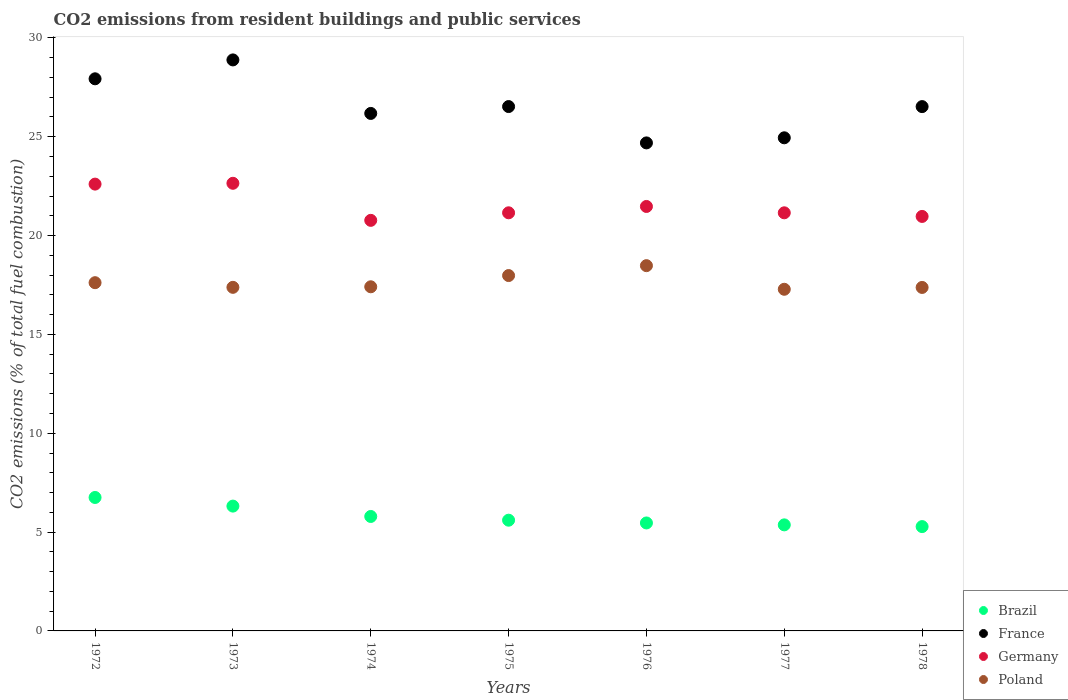Is the number of dotlines equal to the number of legend labels?
Ensure brevity in your answer.  Yes. What is the total CO2 emitted in Poland in 1975?
Offer a terse response. 17.98. Across all years, what is the maximum total CO2 emitted in Poland?
Your response must be concise. 18.48. Across all years, what is the minimum total CO2 emitted in France?
Your answer should be very brief. 24.69. In which year was the total CO2 emitted in Germany maximum?
Keep it short and to the point. 1973. In which year was the total CO2 emitted in France minimum?
Offer a very short reply. 1976. What is the total total CO2 emitted in France in the graph?
Your response must be concise. 185.68. What is the difference between the total CO2 emitted in Germany in 1977 and that in 1978?
Provide a short and direct response. 0.18. What is the difference between the total CO2 emitted in Germany in 1973 and the total CO2 emitted in Brazil in 1972?
Offer a very short reply. 15.89. What is the average total CO2 emitted in Poland per year?
Give a very brief answer. 17.65. In the year 1972, what is the difference between the total CO2 emitted in Germany and total CO2 emitted in Poland?
Provide a short and direct response. 4.99. What is the ratio of the total CO2 emitted in Poland in 1973 to that in 1976?
Ensure brevity in your answer.  0.94. What is the difference between the highest and the second highest total CO2 emitted in Poland?
Offer a terse response. 0.5. What is the difference between the highest and the lowest total CO2 emitted in France?
Your answer should be compact. 4.2. Is the sum of the total CO2 emitted in Germany in 1972 and 1976 greater than the maximum total CO2 emitted in Brazil across all years?
Offer a terse response. Yes. Does the total CO2 emitted in Poland monotonically increase over the years?
Keep it short and to the point. No. Is the total CO2 emitted in Brazil strictly greater than the total CO2 emitted in France over the years?
Your answer should be very brief. No. How many years are there in the graph?
Your answer should be very brief. 7. Are the values on the major ticks of Y-axis written in scientific E-notation?
Give a very brief answer. No. Does the graph contain any zero values?
Make the answer very short. No. Where does the legend appear in the graph?
Ensure brevity in your answer.  Bottom right. What is the title of the graph?
Your answer should be compact. CO2 emissions from resident buildings and public services. What is the label or title of the X-axis?
Your answer should be very brief. Years. What is the label or title of the Y-axis?
Offer a very short reply. CO2 emissions (% of total fuel combustion). What is the CO2 emissions (% of total fuel combustion) in Brazil in 1972?
Your answer should be very brief. 6.75. What is the CO2 emissions (% of total fuel combustion) of France in 1972?
Ensure brevity in your answer.  27.93. What is the CO2 emissions (% of total fuel combustion) of Germany in 1972?
Offer a terse response. 22.6. What is the CO2 emissions (% of total fuel combustion) of Poland in 1972?
Ensure brevity in your answer.  17.62. What is the CO2 emissions (% of total fuel combustion) in Brazil in 1973?
Provide a short and direct response. 6.31. What is the CO2 emissions (% of total fuel combustion) of France in 1973?
Make the answer very short. 28.89. What is the CO2 emissions (% of total fuel combustion) of Germany in 1973?
Your answer should be compact. 22.65. What is the CO2 emissions (% of total fuel combustion) in Poland in 1973?
Offer a terse response. 17.38. What is the CO2 emissions (% of total fuel combustion) of Brazil in 1974?
Your response must be concise. 5.79. What is the CO2 emissions (% of total fuel combustion) of France in 1974?
Keep it short and to the point. 26.18. What is the CO2 emissions (% of total fuel combustion) of Germany in 1974?
Your answer should be very brief. 20.77. What is the CO2 emissions (% of total fuel combustion) of Poland in 1974?
Your answer should be very brief. 17.41. What is the CO2 emissions (% of total fuel combustion) of Brazil in 1975?
Your response must be concise. 5.6. What is the CO2 emissions (% of total fuel combustion) in France in 1975?
Ensure brevity in your answer.  26.53. What is the CO2 emissions (% of total fuel combustion) in Germany in 1975?
Offer a terse response. 21.15. What is the CO2 emissions (% of total fuel combustion) of Poland in 1975?
Give a very brief answer. 17.98. What is the CO2 emissions (% of total fuel combustion) in Brazil in 1976?
Make the answer very short. 5.46. What is the CO2 emissions (% of total fuel combustion) of France in 1976?
Ensure brevity in your answer.  24.69. What is the CO2 emissions (% of total fuel combustion) in Germany in 1976?
Your response must be concise. 21.47. What is the CO2 emissions (% of total fuel combustion) in Poland in 1976?
Provide a succinct answer. 18.48. What is the CO2 emissions (% of total fuel combustion) of Brazil in 1977?
Give a very brief answer. 5.37. What is the CO2 emissions (% of total fuel combustion) of France in 1977?
Offer a very short reply. 24.95. What is the CO2 emissions (% of total fuel combustion) in Germany in 1977?
Ensure brevity in your answer.  21.15. What is the CO2 emissions (% of total fuel combustion) in Poland in 1977?
Give a very brief answer. 17.28. What is the CO2 emissions (% of total fuel combustion) of Brazil in 1978?
Your answer should be compact. 5.28. What is the CO2 emissions (% of total fuel combustion) in France in 1978?
Give a very brief answer. 26.52. What is the CO2 emissions (% of total fuel combustion) in Germany in 1978?
Make the answer very short. 20.97. What is the CO2 emissions (% of total fuel combustion) in Poland in 1978?
Keep it short and to the point. 17.38. Across all years, what is the maximum CO2 emissions (% of total fuel combustion) in Brazil?
Keep it short and to the point. 6.75. Across all years, what is the maximum CO2 emissions (% of total fuel combustion) of France?
Offer a terse response. 28.89. Across all years, what is the maximum CO2 emissions (% of total fuel combustion) in Germany?
Your answer should be compact. 22.65. Across all years, what is the maximum CO2 emissions (% of total fuel combustion) in Poland?
Offer a very short reply. 18.48. Across all years, what is the minimum CO2 emissions (% of total fuel combustion) in Brazil?
Ensure brevity in your answer.  5.28. Across all years, what is the minimum CO2 emissions (% of total fuel combustion) in France?
Provide a succinct answer. 24.69. Across all years, what is the minimum CO2 emissions (% of total fuel combustion) in Germany?
Offer a terse response. 20.77. Across all years, what is the minimum CO2 emissions (% of total fuel combustion) in Poland?
Ensure brevity in your answer.  17.28. What is the total CO2 emissions (% of total fuel combustion) in Brazil in the graph?
Provide a succinct answer. 40.56. What is the total CO2 emissions (% of total fuel combustion) in France in the graph?
Provide a succinct answer. 185.68. What is the total CO2 emissions (% of total fuel combustion) in Germany in the graph?
Provide a short and direct response. 150.76. What is the total CO2 emissions (% of total fuel combustion) in Poland in the graph?
Your answer should be compact. 123.52. What is the difference between the CO2 emissions (% of total fuel combustion) of Brazil in 1972 and that in 1973?
Offer a very short reply. 0.44. What is the difference between the CO2 emissions (% of total fuel combustion) of France in 1972 and that in 1973?
Offer a very short reply. -0.96. What is the difference between the CO2 emissions (% of total fuel combustion) in Germany in 1972 and that in 1973?
Ensure brevity in your answer.  -0.04. What is the difference between the CO2 emissions (% of total fuel combustion) of Poland in 1972 and that in 1973?
Make the answer very short. 0.24. What is the difference between the CO2 emissions (% of total fuel combustion) in Brazil in 1972 and that in 1974?
Offer a terse response. 0.96. What is the difference between the CO2 emissions (% of total fuel combustion) in France in 1972 and that in 1974?
Offer a very short reply. 1.75. What is the difference between the CO2 emissions (% of total fuel combustion) of Germany in 1972 and that in 1974?
Your response must be concise. 1.83. What is the difference between the CO2 emissions (% of total fuel combustion) of Poland in 1972 and that in 1974?
Your response must be concise. 0.21. What is the difference between the CO2 emissions (% of total fuel combustion) in Brazil in 1972 and that in 1975?
Offer a very short reply. 1.15. What is the difference between the CO2 emissions (% of total fuel combustion) of France in 1972 and that in 1975?
Offer a terse response. 1.4. What is the difference between the CO2 emissions (% of total fuel combustion) in Germany in 1972 and that in 1975?
Provide a succinct answer. 1.45. What is the difference between the CO2 emissions (% of total fuel combustion) in Poland in 1972 and that in 1975?
Provide a short and direct response. -0.36. What is the difference between the CO2 emissions (% of total fuel combustion) of Brazil in 1972 and that in 1976?
Your answer should be compact. 1.29. What is the difference between the CO2 emissions (% of total fuel combustion) of France in 1972 and that in 1976?
Your answer should be very brief. 3.24. What is the difference between the CO2 emissions (% of total fuel combustion) of Germany in 1972 and that in 1976?
Your answer should be compact. 1.13. What is the difference between the CO2 emissions (% of total fuel combustion) of Poland in 1972 and that in 1976?
Keep it short and to the point. -0.86. What is the difference between the CO2 emissions (% of total fuel combustion) of Brazil in 1972 and that in 1977?
Offer a terse response. 1.39. What is the difference between the CO2 emissions (% of total fuel combustion) of France in 1972 and that in 1977?
Keep it short and to the point. 2.98. What is the difference between the CO2 emissions (% of total fuel combustion) of Germany in 1972 and that in 1977?
Your response must be concise. 1.45. What is the difference between the CO2 emissions (% of total fuel combustion) in Poland in 1972 and that in 1977?
Make the answer very short. 0.33. What is the difference between the CO2 emissions (% of total fuel combustion) in Brazil in 1972 and that in 1978?
Make the answer very short. 1.47. What is the difference between the CO2 emissions (% of total fuel combustion) of France in 1972 and that in 1978?
Offer a very short reply. 1.41. What is the difference between the CO2 emissions (% of total fuel combustion) of Germany in 1972 and that in 1978?
Ensure brevity in your answer.  1.63. What is the difference between the CO2 emissions (% of total fuel combustion) in Poland in 1972 and that in 1978?
Your answer should be compact. 0.24. What is the difference between the CO2 emissions (% of total fuel combustion) of Brazil in 1973 and that in 1974?
Keep it short and to the point. 0.52. What is the difference between the CO2 emissions (% of total fuel combustion) in France in 1973 and that in 1974?
Make the answer very short. 2.71. What is the difference between the CO2 emissions (% of total fuel combustion) in Germany in 1973 and that in 1974?
Provide a succinct answer. 1.87. What is the difference between the CO2 emissions (% of total fuel combustion) of Poland in 1973 and that in 1974?
Your answer should be compact. -0.03. What is the difference between the CO2 emissions (% of total fuel combustion) of Brazil in 1973 and that in 1975?
Provide a short and direct response. 0.71. What is the difference between the CO2 emissions (% of total fuel combustion) of France in 1973 and that in 1975?
Provide a short and direct response. 2.36. What is the difference between the CO2 emissions (% of total fuel combustion) of Germany in 1973 and that in 1975?
Make the answer very short. 1.49. What is the difference between the CO2 emissions (% of total fuel combustion) in Poland in 1973 and that in 1975?
Your response must be concise. -0.6. What is the difference between the CO2 emissions (% of total fuel combustion) in Brazil in 1973 and that in 1976?
Your response must be concise. 0.85. What is the difference between the CO2 emissions (% of total fuel combustion) of France in 1973 and that in 1976?
Keep it short and to the point. 4.2. What is the difference between the CO2 emissions (% of total fuel combustion) in Germany in 1973 and that in 1976?
Your answer should be compact. 1.17. What is the difference between the CO2 emissions (% of total fuel combustion) of Poland in 1973 and that in 1976?
Offer a terse response. -1.1. What is the difference between the CO2 emissions (% of total fuel combustion) of Brazil in 1973 and that in 1977?
Offer a very short reply. 0.95. What is the difference between the CO2 emissions (% of total fuel combustion) of France in 1973 and that in 1977?
Your answer should be compact. 3.94. What is the difference between the CO2 emissions (% of total fuel combustion) in Germany in 1973 and that in 1977?
Provide a succinct answer. 1.49. What is the difference between the CO2 emissions (% of total fuel combustion) of Poland in 1973 and that in 1977?
Offer a terse response. 0.1. What is the difference between the CO2 emissions (% of total fuel combustion) of Brazil in 1973 and that in 1978?
Your answer should be very brief. 1.04. What is the difference between the CO2 emissions (% of total fuel combustion) of France in 1973 and that in 1978?
Ensure brevity in your answer.  2.36. What is the difference between the CO2 emissions (% of total fuel combustion) of Germany in 1973 and that in 1978?
Give a very brief answer. 1.68. What is the difference between the CO2 emissions (% of total fuel combustion) of Poland in 1973 and that in 1978?
Offer a very short reply. 0.01. What is the difference between the CO2 emissions (% of total fuel combustion) of Brazil in 1974 and that in 1975?
Provide a succinct answer. 0.19. What is the difference between the CO2 emissions (% of total fuel combustion) of France in 1974 and that in 1975?
Give a very brief answer. -0.35. What is the difference between the CO2 emissions (% of total fuel combustion) in Germany in 1974 and that in 1975?
Your response must be concise. -0.38. What is the difference between the CO2 emissions (% of total fuel combustion) in Poland in 1974 and that in 1975?
Your response must be concise. -0.57. What is the difference between the CO2 emissions (% of total fuel combustion) of Brazil in 1974 and that in 1976?
Your answer should be very brief. 0.33. What is the difference between the CO2 emissions (% of total fuel combustion) of France in 1974 and that in 1976?
Ensure brevity in your answer.  1.49. What is the difference between the CO2 emissions (% of total fuel combustion) in Germany in 1974 and that in 1976?
Your answer should be very brief. -0.7. What is the difference between the CO2 emissions (% of total fuel combustion) of Poland in 1974 and that in 1976?
Your answer should be compact. -1.07. What is the difference between the CO2 emissions (% of total fuel combustion) of Brazil in 1974 and that in 1977?
Provide a succinct answer. 0.42. What is the difference between the CO2 emissions (% of total fuel combustion) in France in 1974 and that in 1977?
Offer a terse response. 1.23. What is the difference between the CO2 emissions (% of total fuel combustion) in Germany in 1974 and that in 1977?
Keep it short and to the point. -0.38. What is the difference between the CO2 emissions (% of total fuel combustion) in Poland in 1974 and that in 1977?
Offer a very short reply. 0.13. What is the difference between the CO2 emissions (% of total fuel combustion) in Brazil in 1974 and that in 1978?
Provide a short and direct response. 0.51. What is the difference between the CO2 emissions (% of total fuel combustion) of France in 1974 and that in 1978?
Provide a succinct answer. -0.35. What is the difference between the CO2 emissions (% of total fuel combustion) in Germany in 1974 and that in 1978?
Provide a short and direct response. -0.2. What is the difference between the CO2 emissions (% of total fuel combustion) of Poland in 1974 and that in 1978?
Offer a very short reply. 0.03. What is the difference between the CO2 emissions (% of total fuel combustion) of Brazil in 1975 and that in 1976?
Provide a succinct answer. 0.14. What is the difference between the CO2 emissions (% of total fuel combustion) of France in 1975 and that in 1976?
Keep it short and to the point. 1.84. What is the difference between the CO2 emissions (% of total fuel combustion) of Germany in 1975 and that in 1976?
Keep it short and to the point. -0.32. What is the difference between the CO2 emissions (% of total fuel combustion) of Poland in 1975 and that in 1976?
Your answer should be compact. -0.5. What is the difference between the CO2 emissions (% of total fuel combustion) of Brazil in 1975 and that in 1977?
Offer a terse response. 0.24. What is the difference between the CO2 emissions (% of total fuel combustion) of France in 1975 and that in 1977?
Keep it short and to the point. 1.58. What is the difference between the CO2 emissions (% of total fuel combustion) of Poland in 1975 and that in 1977?
Your answer should be compact. 0.69. What is the difference between the CO2 emissions (% of total fuel combustion) in Brazil in 1975 and that in 1978?
Ensure brevity in your answer.  0.32. What is the difference between the CO2 emissions (% of total fuel combustion) in France in 1975 and that in 1978?
Your response must be concise. 0. What is the difference between the CO2 emissions (% of total fuel combustion) in Germany in 1975 and that in 1978?
Provide a succinct answer. 0.18. What is the difference between the CO2 emissions (% of total fuel combustion) in Poland in 1975 and that in 1978?
Your answer should be compact. 0.6. What is the difference between the CO2 emissions (% of total fuel combustion) of Brazil in 1976 and that in 1977?
Offer a very short reply. 0.1. What is the difference between the CO2 emissions (% of total fuel combustion) in France in 1976 and that in 1977?
Provide a succinct answer. -0.26. What is the difference between the CO2 emissions (% of total fuel combustion) in Germany in 1976 and that in 1977?
Give a very brief answer. 0.32. What is the difference between the CO2 emissions (% of total fuel combustion) in Poland in 1976 and that in 1977?
Give a very brief answer. 1.2. What is the difference between the CO2 emissions (% of total fuel combustion) in Brazil in 1976 and that in 1978?
Provide a short and direct response. 0.18. What is the difference between the CO2 emissions (% of total fuel combustion) of France in 1976 and that in 1978?
Your response must be concise. -1.84. What is the difference between the CO2 emissions (% of total fuel combustion) of Germany in 1976 and that in 1978?
Your answer should be compact. 0.5. What is the difference between the CO2 emissions (% of total fuel combustion) in Poland in 1976 and that in 1978?
Provide a short and direct response. 1.1. What is the difference between the CO2 emissions (% of total fuel combustion) in Brazil in 1977 and that in 1978?
Give a very brief answer. 0.09. What is the difference between the CO2 emissions (% of total fuel combustion) of France in 1977 and that in 1978?
Your answer should be compact. -1.58. What is the difference between the CO2 emissions (% of total fuel combustion) of Germany in 1977 and that in 1978?
Offer a terse response. 0.18. What is the difference between the CO2 emissions (% of total fuel combustion) in Poland in 1977 and that in 1978?
Give a very brief answer. -0.09. What is the difference between the CO2 emissions (% of total fuel combustion) in Brazil in 1972 and the CO2 emissions (% of total fuel combustion) in France in 1973?
Provide a succinct answer. -22.14. What is the difference between the CO2 emissions (% of total fuel combustion) in Brazil in 1972 and the CO2 emissions (% of total fuel combustion) in Germany in 1973?
Provide a short and direct response. -15.89. What is the difference between the CO2 emissions (% of total fuel combustion) in Brazil in 1972 and the CO2 emissions (% of total fuel combustion) in Poland in 1973?
Your response must be concise. -10.63. What is the difference between the CO2 emissions (% of total fuel combustion) of France in 1972 and the CO2 emissions (% of total fuel combustion) of Germany in 1973?
Make the answer very short. 5.29. What is the difference between the CO2 emissions (% of total fuel combustion) of France in 1972 and the CO2 emissions (% of total fuel combustion) of Poland in 1973?
Ensure brevity in your answer.  10.55. What is the difference between the CO2 emissions (% of total fuel combustion) of Germany in 1972 and the CO2 emissions (% of total fuel combustion) of Poland in 1973?
Keep it short and to the point. 5.22. What is the difference between the CO2 emissions (% of total fuel combustion) of Brazil in 1972 and the CO2 emissions (% of total fuel combustion) of France in 1974?
Provide a short and direct response. -19.43. What is the difference between the CO2 emissions (% of total fuel combustion) in Brazil in 1972 and the CO2 emissions (% of total fuel combustion) in Germany in 1974?
Keep it short and to the point. -14.02. What is the difference between the CO2 emissions (% of total fuel combustion) of Brazil in 1972 and the CO2 emissions (% of total fuel combustion) of Poland in 1974?
Your response must be concise. -10.66. What is the difference between the CO2 emissions (% of total fuel combustion) in France in 1972 and the CO2 emissions (% of total fuel combustion) in Germany in 1974?
Ensure brevity in your answer.  7.16. What is the difference between the CO2 emissions (% of total fuel combustion) of France in 1972 and the CO2 emissions (% of total fuel combustion) of Poland in 1974?
Offer a very short reply. 10.52. What is the difference between the CO2 emissions (% of total fuel combustion) of Germany in 1972 and the CO2 emissions (% of total fuel combustion) of Poland in 1974?
Make the answer very short. 5.19. What is the difference between the CO2 emissions (% of total fuel combustion) in Brazil in 1972 and the CO2 emissions (% of total fuel combustion) in France in 1975?
Ensure brevity in your answer.  -19.78. What is the difference between the CO2 emissions (% of total fuel combustion) in Brazil in 1972 and the CO2 emissions (% of total fuel combustion) in Germany in 1975?
Your answer should be very brief. -14.4. What is the difference between the CO2 emissions (% of total fuel combustion) in Brazil in 1972 and the CO2 emissions (% of total fuel combustion) in Poland in 1975?
Your response must be concise. -11.23. What is the difference between the CO2 emissions (% of total fuel combustion) of France in 1972 and the CO2 emissions (% of total fuel combustion) of Germany in 1975?
Provide a succinct answer. 6.78. What is the difference between the CO2 emissions (% of total fuel combustion) of France in 1972 and the CO2 emissions (% of total fuel combustion) of Poland in 1975?
Offer a very short reply. 9.95. What is the difference between the CO2 emissions (% of total fuel combustion) of Germany in 1972 and the CO2 emissions (% of total fuel combustion) of Poland in 1975?
Make the answer very short. 4.63. What is the difference between the CO2 emissions (% of total fuel combustion) in Brazil in 1972 and the CO2 emissions (% of total fuel combustion) in France in 1976?
Your answer should be compact. -17.94. What is the difference between the CO2 emissions (% of total fuel combustion) of Brazil in 1972 and the CO2 emissions (% of total fuel combustion) of Germany in 1976?
Your answer should be compact. -14.72. What is the difference between the CO2 emissions (% of total fuel combustion) of Brazil in 1972 and the CO2 emissions (% of total fuel combustion) of Poland in 1976?
Your answer should be compact. -11.73. What is the difference between the CO2 emissions (% of total fuel combustion) of France in 1972 and the CO2 emissions (% of total fuel combustion) of Germany in 1976?
Make the answer very short. 6.46. What is the difference between the CO2 emissions (% of total fuel combustion) in France in 1972 and the CO2 emissions (% of total fuel combustion) in Poland in 1976?
Your answer should be compact. 9.45. What is the difference between the CO2 emissions (% of total fuel combustion) of Germany in 1972 and the CO2 emissions (% of total fuel combustion) of Poland in 1976?
Your response must be concise. 4.13. What is the difference between the CO2 emissions (% of total fuel combustion) in Brazil in 1972 and the CO2 emissions (% of total fuel combustion) in France in 1977?
Your answer should be very brief. -18.2. What is the difference between the CO2 emissions (% of total fuel combustion) of Brazil in 1972 and the CO2 emissions (% of total fuel combustion) of Germany in 1977?
Your answer should be very brief. -14.4. What is the difference between the CO2 emissions (% of total fuel combustion) of Brazil in 1972 and the CO2 emissions (% of total fuel combustion) of Poland in 1977?
Offer a very short reply. -10.53. What is the difference between the CO2 emissions (% of total fuel combustion) of France in 1972 and the CO2 emissions (% of total fuel combustion) of Germany in 1977?
Offer a very short reply. 6.78. What is the difference between the CO2 emissions (% of total fuel combustion) in France in 1972 and the CO2 emissions (% of total fuel combustion) in Poland in 1977?
Your answer should be compact. 10.65. What is the difference between the CO2 emissions (% of total fuel combustion) in Germany in 1972 and the CO2 emissions (% of total fuel combustion) in Poland in 1977?
Offer a very short reply. 5.32. What is the difference between the CO2 emissions (% of total fuel combustion) in Brazil in 1972 and the CO2 emissions (% of total fuel combustion) in France in 1978?
Provide a short and direct response. -19.77. What is the difference between the CO2 emissions (% of total fuel combustion) of Brazil in 1972 and the CO2 emissions (% of total fuel combustion) of Germany in 1978?
Offer a terse response. -14.22. What is the difference between the CO2 emissions (% of total fuel combustion) of Brazil in 1972 and the CO2 emissions (% of total fuel combustion) of Poland in 1978?
Provide a succinct answer. -10.63. What is the difference between the CO2 emissions (% of total fuel combustion) in France in 1972 and the CO2 emissions (% of total fuel combustion) in Germany in 1978?
Ensure brevity in your answer.  6.96. What is the difference between the CO2 emissions (% of total fuel combustion) of France in 1972 and the CO2 emissions (% of total fuel combustion) of Poland in 1978?
Offer a terse response. 10.55. What is the difference between the CO2 emissions (% of total fuel combustion) in Germany in 1972 and the CO2 emissions (% of total fuel combustion) in Poland in 1978?
Provide a succinct answer. 5.23. What is the difference between the CO2 emissions (% of total fuel combustion) of Brazil in 1973 and the CO2 emissions (% of total fuel combustion) of France in 1974?
Offer a terse response. -19.87. What is the difference between the CO2 emissions (% of total fuel combustion) in Brazil in 1973 and the CO2 emissions (% of total fuel combustion) in Germany in 1974?
Offer a terse response. -14.46. What is the difference between the CO2 emissions (% of total fuel combustion) in Brazil in 1973 and the CO2 emissions (% of total fuel combustion) in Poland in 1974?
Provide a short and direct response. -11.09. What is the difference between the CO2 emissions (% of total fuel combustion) in France in 1973 and the CO2 emissions (% of total fuel combustion) in Germany in 1974?
Give a very brief answer. 8.12. What is the difference between the CO2 emissions (% of total fuel combustion) of France in 1973 and the CO2 emissions (% of total fuel combustion) of Poland in 1974?
Keep it short and to the point. 11.48. What is the difference between the CO2 emissions (% of total fuel combustion) in Germany in 1973 and the CO2 emissions (% of total fuel combustion) in Poland in 1974?
Provide a short and direct response. 5.24. What is the difference between the CO2 emissions (% of total fuel combustion) of Brazil in 1973 and the CO2 emissions (% of total fuel combustion) of France in 1975?
Your response must be concise. -20.21. What is the difference between the CO2 emissions (% of total fuel combustion) in Brazil in 1973 and the CO2 emissions (% of total fuel combustion) in Germany in 1975?
Offer a very short reply. -14.84. What is the difference between the CO2 emissions (% of total fuel combustion) of Brazil in 1973 and the CO2 emissions (% of total fuel combustion) of Poland in 1975?
Your response must be concise. -11.66. What is the difference between the CO2 emissions (% of total fuel combustion) in France in 1973 and the CO2 emissions (% of total fuel combustion) in Germany in 1975?
Your answer should be very brief. 7.74. What is the difference between the CO2 emissions (% of total fuel combustion) of France in 1973 and the CO2 emissions (% of total fuel combustion) of Poland in 1975?
Your response must be concise. 10.91. What is the difference between the CO2 emissions (% of total fuel combustion) in Germany in 1973 and the CO2 emissions (% of total fuel combustion) in Poland in 1975?
Provide a succinct answer. 4.67. What is the difference between the CO2 emissions (% of total fuel combustion) in Brazil in 1973 and the CO2 emissions (% of total fuel combustion) in France in 1976?
Your answer should be compact. -18.37. What is the difference between the CO2 emissions (% of total fuel combustion) of Brazil in 1973 and the CO2 emissions (% of total fuel combustion) of Germany in 1976?
Your answer should be very brief. -15.16. What is the difference between the CO2 emissions (% of total fuel combustion) in Brazil in 1973 and the CO2 emissions (% of total fuel combustion) in Poland in 1976?
Your answer should be compact. -12.16. What is the difference between the CO2 emissions (% of total fuel combustion) in France in 1973 and the CO2 emissions (% of total fuel combustion) in Germany in 1976?
Ensure brevity in your answer.  7.41. What is the difference between the CO2 emissions (% of total fuel combustion) in France in 1973 and the CO2 emissions (% of total fuel combustion) in Poland in 1976?
Your answer should be compact. 10.41. What is the difference between the CO2 emissions (% of total fuel combustion) of Germany in 1973 and the CO2 emissions (% of total fuel combustion) of Poland in 1976?
Provide a short and direct response. 4.17. What is the difference between the CO2 emissions (% of total fuel combustion) of Brazil in 1973 and the CO2 emissions (% of total fuel combustion) of France in 1977?
Your response must be concise. -18.63. What is the difference between the CO2 emissions (% of total fuel combustion) in Brazil in 1973 and the CO2 emissions (% of total fuel combustion) in Germany in 1977?
Make the answer very short. -14.84. What is the difference between the CO2 emissions (% of total fuel combustion) of Brazil in 1973 and the CO2 emissions (% of total fuel combustion) of Poland in 1977?
Offer a terse response. -10.97. What is the difference between the CO2 emissions (% of total fuel combustion) of France in 1973 and the CO2 emissions (% of total fuel combustion) of Germany in 1977?
Your response must be concise. 7.74. What is the difference between the CO2 emissions (% of total fuel combustion) in France in 1973 and the CO2 emissions (% of total fuel combustion) in Poland in 1977?
Ensure brevity in your answer.  11.6. What is the difference between the CO2 emissions (% of total fuel combustion) in Germany in 1973 and the CO2 emissions (% of total fuel combustion) in Poland in 1977?
Make the answer very short. 5.36. What is the difference between the CO2 emissions (% of total fuel combustion) in Brazil in 1973 and the CO2 emissions (% of total fuel combustion) in France in 1978?
Offer a terse response. -20.21. What is the difference between the CO2 emissions (% of total fuel combustion) in Brazil in 1973 and the CO2 emissions (% of total fuel combustion) in Germany in 1978?
Your answer should be compact. -14.65. What is the difference between the CO2 emissions (% of total fuel combustion) in Brazil in 1973 and the CO2 emissions (% of total fuel combustion) in Poland in 1978?
Provide a short and direct response. -11.06. What is the difference between the CO2 emissions (% of total fuel combustion) in France in 1973 and the CO2 emissions (% of total fuel combustion) in Germany in 1978?
Your answer should be very brief. 7.92. What is the difference between the CO2 emissions (% of total fuel combustion) in France in 1973 and the CO2 emissions (% of total fuel combustion) in Poland in 1978?
Your response must be concise. 11.51. What is the difference between the CO2 emissions (% of total fuel combustion) of Germany in 1973 and the CO2 emissions (% of total fuel combustion) of Poland in 1978?
Your answer should be compact. 5.27. What is the difference between the CO2 emissions (% of total fuel combustion) in Brazil in 1974 and the CO2 emissions (% of total fuel combustion) in France in 1975?
Ensure brevity in your answer.  -20.74. What is the difference between the CO2 emissions (% of total fuel combustion) in Brazil in 1974 and the CO2 emissions (% of total fuel combustion) in Germany in 1975?
Ensure brevity in your answer.  -15.36. What is the difference between the CO2 emissions (% of total fuel combustion) in Brazil in 1974 and the CO2 emissions (% of total fuel combustion) in Poland in 1975?
Offer a very short reply. -12.19. What is the difference between the CO2 emissions (% of total fuel combustion) in France in 1974 and the CO2 emissions (% of total fuel combustion) in Germany in 1975?
Your response must be concise. 5.03. What is the difference between the CO2 emissions (% of total fuel combustion) in France in 1974 and the CO2 emissions (% of total fuel combustion) in Poland in 1975?
Provide a short and direct response. 8.2. What is the difference between the CO2 emissions (% of total fuel combustion) of Germany in 1974 and the CO2 emissions (% of total fuel combustion) of Poland in 1975?
Make the answer very short. 2.79. What is the difference between the CO2 emissions (% of total fuel combustion) in Brazil in 1974 and the CO2 emissions (% of total fuel combustion) in France in 1976?
Keep it short and to the point. -18.9. What is the difference between the CO2 emissions (% of total fuel combustion) of Brazil in 1974 and the CO2 emissions (% of total fuel combustion) of Germany in 1976?
Make the answer very short. -15.68. What is the difference between the CO2 emissions (% of total fuel combustion) in Brazil in 1974 and the CO2 emissions (% of total fuel combustion) in Poland in 1976?
Your response must be concise. -12.69. What is the difference between the CO2 emissions (% of total fuel combustion) in France in 1974 and the CO2 emissions (% of total fuel combustion) in Germany in 1976?
Make the answer very short. 4.71. What is the difference between the CO2 emissions (% of total fuel combustion) of France in 1974 and the CO2 emissions (% of total fuel combustion) of Poland in 1976?
Offer a very short reply. 7.7. What is the difference between the CO2 emissions (% of total fuel combustion) of Germany in 1974 and the CO2 emissions (% of total fuel combustion) of Poland in 1976?
Offer a very short reply. 2.29. What is the difference between the CO2 emissions (% of total fuel combustion) of Brazil in 1974 and the CO2 emissions (% of total fuel combustion) of France in 1977?
Your response must be concise. -19.16. What is the difference between the CO2 emissions (% of total fuel combustion) in Brazil in 1974 and the CO2 emissions (% of total fuel combustion) in Germany in 1977?
Ensure brevity in your answer.  -15.36. What is the difference between the CO2 emissions (% of total fuel combustion) of Brazil in 1974 and the CO2 emissions (% of total fuel combustion) of Poland in 1977?
Provide a succinct answer. -11.49. What is the difference between the CO2 emissions (% of total fuel combustion) of France in 1974 and the CO2 emissions (% of total fuel combustion) of Germany in 1977?
Your answer should be compact. 5.03. What is the difference between the CO2 emissions (% of total fuel combustion) of France in 1974 and the CO2 emissions (% of total fuel combustion) of Poland in 1977?
Offer a very short reply. 8.9. What is the difference between the CO2 emissions (% of total fuel combustion) of Germany in 1974 and the CO2 emissions (% of total fuel combustion) of Poland in 1977?
Ensure brevity in your answer.  3.49. What is the difference between the CO2 emissions (% of total fuel combustion) of Brazil in 1974 and the CO2 emissions (% of total fuel combustion) of France in 1978?
Make the answer very short. -20.73. What is the difference between the CO2 emissions (% of total fuel combustion) of Brazil in 1974 and the CO2 emissions (% of total fuel combustion) of Germany in 1978?
Give a very brief answer. -15.18. What is the difference between the CO2 emissions (% of total fuel combustion) in Brazil in 1974 and the CO2 emissions (% of total fuel combustion) in Poland in 1978?
Your answer should be very brief. -11.59. What is the difference between the CO2 emissions (% of total fuel combustion) of France in 1974 and the CO2 emissions (% of total fuel combustion) of Germany in 1978?
Offer a very short reply. 5.21. What is the difference between the CO2 emissions (% of total fuel combustion) in France in 1974 and the CO2 emissions (% of total fuel combustion) in Poland in 1978?
Offer a very short reply. 8.8. What is the difference between the CO2 emissions (% of total fuel combustion) of Germany in 1974 and the CO2 emissions (% of total fuel combustion) of Poland in 1978?
Your answer should be compact. 3.39. What is the difference between the CO2 emissions (% of total fuel combustion) of Brazil in 1975 and the CO2 emissions (% of total fuel combustion) of France in 1976?
Your answer should be compact. -19.09. What is the difference between the CO2 emissions (% of total fuel combustion) in Brazil in 1975 and the CO2 emissions (% of total fuel combustion) in Germany in 1976?
Ensure brevity in your answer.  -15.87. What is the difference between the CO2 emissions (% of total fuel combustion) in Brazil in 1975 and the CO2 emissions (% of total fuel combustion) in Poland in 1976?
Offer a terse response. -12.88. What is the difference between the CO2 emissions (% of total fuel combustion) in France in 1975 and the CO2 emissions (% of total fuel combustion) in Germany in 1976?
Give a very brief answer. 5.05. What is the difference between the CO2 emissions (% of total fuel combustion) of France in 1975 and the CO2 emissions (% of total fuel combustion) of Poland in 1976?
Your response must be concise. 8.05. What is the difference between the CO2 emissions (% of total fuel combustion) in Germany in 1975 and the CO2 emissions (% of total fuel combustion) in Poland in 1976?
Ensure brevity in your answer.  2.67. What is the difference between the CO2 emissions (% of total fuel combustion) of Brazil in 1975 and the CO2 emissions (% of total fuel combustion) of France in 1977?
Ensure brevity in your answer.  -19.34. What is the difference between the CO2 emissions (% of total fuel combustion) of Brazil in 1975 and the CO2 emissions (% of total fuel combustion) of Germany in 1977?
Ensure brevity in your answer.  -15.55. What is the difference between the CO2 emissions (% of total fuel combustion) in Brazil in 1975 and the CO2 emissions (% of total fuel combustion) in Poland in 1977?
Your answer should be compact. -11.68. What is the difference between the CO2 emissions (% of total fuel combustion) in France in 1975 and the CO2 emissions (% of total fuel combustion) in Germany in 1977?
Your answer should be very brief. 5.38. What is the difference between the CO2 emissions (% of total fuel combustion) in France in 1975 and the CO2 emissions (% of total fuel combustion) in Poland in 1977?
Make the answer very short. 9.24. What is the difference between the CO2 emissions (% of total fuel combustion) of Germany in 1975 and the CO2 emissions (% of total fuel combustion) of Poland in 1977?
Provide a succinct answer. 3.87. What is the difference between the CO2 emissions (% of total fuel combustion) of Brazil in 1975 and the CO2 emissions (% of total fuel combustion) of France in 1978?
Ensure brevity in your answer.  -20.92. What is the difference between the CO2 emissions (% of total fuel combustion) in Brazil in 1975 and the CO2 emissions (% of total fuel combustion) in Germany in 1978?
Provide a short and direct response. -15.37. What is the difference between the CO2 emissions (% of total fuel combustion) in Brazil in 1975 and the CO2 emissions (% of total fuel combustion) in Poland in 1978?
Give a very brief answer. -11.77. What is the difference between the CO2 emissions (% of total fuel combustion) of France in 1975 and the CO2 emissions (% of total fuel combustion) of Germany in 1978?
Your answer should be very brief. 5.56. What is the difference between the CO2 emissions (% of total fuel combustion) in France in 1975 and the CO2 emissions (% of total fuel combustion) in Poland in 1978?
Your answer should be compact. 9.15. What is the difference between the CO2 emissions (% of total fuel combustion) of Germany in 1975 and the CO2 emissions (% of total fuel combustion) of Poland in 1978?
Make the answer very short. 3.78. What is the difference between the CO2 emissions (% of total fuel combustion) of Brazil in 1976 and the CO2 emissions (% of total fuel combustion) of France in 1977?
Give a very brief answer. -19.48. What is the difference between the CO2 emissions (% of total fuel combustion) in Brazil in 1976 and the CO2 emissions (% of total fuel combustion) in Germany in 1977?
Give a very brief answer. -15.69. What is the difference between the CO2 emissions (% of total fuel combustion) in Brazil in 1976 and the CO2 emissions (% of total fuel combustion) in Poland in 1977?
Offer a very short reply. -11.82. What is the difference between the CO2 emissions (% of total fuel combustion) in France in 1976 and the CO2 emissions (% of total fuel combustion) in Germany in 1977?
Offer a very short reply. 3.54. What is the difference between the CO2 emissions (% of total fuel combustion) of France in 1976 and the CO2 emissions (% of total fuel combustion) of Poland in 1977?
Your answer should be very brief. 7.41. What is the difference between the CO2 emissions (% of total fuel combustion) in Germany in 1976 and the CO2 emissions (% of total fuel combustion) in Poland in 1977?
Offer a very short reply. 4.19. What is the difference between the CO2 emissions (% of total fuel combustion) in Brazil in 1976 and the CO2 emissions (% of total fuel combustion) in France in 1978?
Offer a terse response. -21.06. What is the difference between the CO2 emissions (% of total fuel combustion) of Brazil in 1976 and the CO2 emissions (% of total fuel combustion) of Germany in 1978?
Your answer should be compact. -15.51. What is the difference between the CO2 emissions (% of total fuel combustion) of Brazil in 1976 and the CO2 emissions (% of total fuel combustion) of Poland in 1978?
Offer a very short reply. -11.91. What is the difference between the CO2 emissions (% of total fuel combustion) in France in 1976 and the CO2 emissions (% of total fuel combustion) in Germany in 1978?
Your answer should be compact. 3.72. What is the difference between the CO2 emissions (% of total fuel combustion) in France in 1976 and the CO2 emissions (% of total fuel combustion) in Poland in 1978?
Make the answer very short. 7.31. What is the difference between the CO2 emissions (% of total fuel combustion) in Germany in 1976 and the CO2 emissions (% of total fuel combustion) in Poland in 1978?
Provide a succinct answer. 4.1. What is the difference between the CO2 emissions (% of total fuel combustion) of Brazil in 1977 and the CO2 emissions (% of total fuel combustion) of France in 1978?
Offer a terse response. -21.16. What is the difference between the CO2 emissions (% of total fuel combustion) of Brazil in 1977 and the CO2 emissions (% of total fuel combustion) of Germany in 1978?
Give a very brief answer. -15.6. What is the difference between the CO2 emissions (% of total fuel combustion) in Brazil in 1977 and the CO2 emissions (% of total fuel combustion) in Poland in 1978?
Your response must be concise. -12.01. What is the difference between the CO2 emissions (% of total fuel combustion) of France in 1977 and the CO2 emissions (% of total fuel combustion) of Germany in 1978?
Your response must be concise. 3.98. What is the difference between the CO2 emissions (% of total fuel combustion) in France in 1977 and the CO2 emissions (% of total fuel combustion) in Poland in 1978?
Provide a succinct answer. 7.57. What is the difference between the CO2 emissions (% of total fuel combustion) in Germany in 1977 and the CO2 emissions (% of total fuel combustion) in Poland in 1978?
Your answer should be very brief. 3.78. What is the average CO2 emissions (% of total fuel combustion) of Brazil per year?
Keep it short and to the point. 5.79. What is the average CO2 emissions (% of total fuel combustion) in France per year?
Provide a succinct answer. 26.53. What is the average CO2 emissions (% of total fuel combustion) of Germany per year?
Your answer should be very brief. 21.54. What is the average CO2 emissions (% of total fuel combustion) of Poland per year?
Give a very brief answer. 17.65. In the year 1972, what is the difference between the CO2 emissions (% of total fuel combustion) in Brazil and CO2 emissions (% of total fuel combustion) in France?
Your answer should be compact. -21.18. In the year 1972, what is the difference between the CO2 emissions (% of total fuel combustion) of Brazil and CO2 emissions (% of total fuel combustion) of Germany?
Offer a very short reply. -15.85. In the year 1972, what is the difference between the CO2 emissions (% of total fuel combustion) in Brazil and CO2 emissions (% of total fuel combustion) in Poland?
Offer a terse response. -10.87. In the year 1972, what is the difference between the CO2 emissions (% of total fuel combustion) in France and CO2 emissions (% of total fuel combustion) in Germany?
Offer a very short reply. 5.33. In the year 1972, what is the difference between the CO2 emissions (% of total fuel combustion) in France and CO2 emissions (% of total fuel combustion) in Poland?
Your answer should be very brief. 10.31. In the year 1972, what is the difference between the CO2 emissions (% of total fuel combustion) in Germany and CO2 emissions (% of total fuel combustion) in Poland?
Your answer should be very brief. 4.99. In the year 1973, what is the difference between the CO2 emissions (% of total fuel combustion) of Brazil and CO2 emissions (% of total fuel combustion) of France?
Provide a short and direct response. -22.57. In the year 1973, what is the difference between the CO2 emissions (% of total fuel combustion) of Brazil and CO2 emissions (% of total fuel combustion) of Germany?
Provide a short and direct response. -16.33. In the year 1973, what is the difference between the CO2 emissions (% of total fuel combustion) of Brazil and CO2 emissions (% of total fuel combustion) of Poland?
Your answer should be very brief. -11.07. In the year 1973, what is the difference between the CO2 emissions (% of total fuel combustion) of France and CO2 emissions (% of total fuel combustion) of Germany?
Give a very brief answer. 6.24. In the year 1973, what is the difference between the CO2 emissions (% of total fuel combustion) in France and CO2 emissions (% of total fuel combustion) in Poland?
Ensure brevity in your answer.  11.51. In the year 1973, what is the difference between the CO2 emissions (% of total fuel combustion) of Germany and CO2 emissions (% of total fuel combustion) of Poland?
Offer a terse response. 5.26. In the year 1974, what is the difference between the CO2 emissions (% of total fuel combustion) in Brazil and CO2 emissions (% of total fuel combustion) in France?
Make the answer very short. -20.39. In the year 1974, what is the difference between the CO2 emissions (% of total fuel combustion) of Brazil and CO2 emissions (% of total fuel combustion) of Germany?
Offer a very short reply. -14.98. In the year 1974, what is the difference between the CO2 emissions (% of total fuel combustion) of Brazil and CO2 emissions (% of total fuel combustion) of Poland?
Keep it short and to the point. -11.62. In the year 1974, what is the difference between the CO2 emissions (% of total fuel combustion) of France and CO2 emissions (% of total fuel combustion) of Germany?
Ensure brevity in your answer.  5.41. In the year 1974, what is the difference between the CO2 emissions (% of total fuel combustion) of France and CO2 emissions (% of total fuel combustion) of Poland?
Offer a very short reply. 8.77. In the year 1974, what is the difference between the CO2 emissions (% of total fuel combustion) of Germany and CO2 emissions (% of total fuel combustion) of Poland?
Keep it short and to the point. 3.36. In the year 1975, what is the difference between the CO2 emissions (% of total fuel combustion) of Brazil and CO2 emissions (% of total fuel combustion) of France?
Offer a very short reply. -20.93. In the year 1975, what is the difference between the CO2 emissions (% of total fuel combustion) in Brazil and CO2 emissions (% of total fuel combustion) in Germany?
Offer a very short reply. -15.55. In the year 1975, what is the difference between the CO2 emissions (% of total fuel combustion) of Brazil and CO2 emissions (% of total fuel combustion) of Poland?
Provide a succinct answer. -12.38. In the year 1975, what is the difference between the CO2 emissions (% of total fuel combustion) of France and CO2 emissions (% of total fuel combustion) of Germany?
Your response must be concise. 5.37. In the year 1975, what is the difference between the CO2 emissions (% of total fuel combustion) in France and CO2 emissions (% of total fuel combustion) in Poland?
Offer a terse response. 8.55. In the year 1975, what is the difference between the CO2 emissions (% of total fuel combustion) in Germany and CO2 emissions (% of total fuel combustion) in Poland?
Provide a succinct answer. 3.17. In the year 1976, what is the difference between the CO2 emissions (% of total fuel combustion) of Brazil and CO2 emissions (% of total fuel combustion) of France?
Your response must be concise. -19.23. In the year 1976, what is the difference between the CO2 emissions (% of total fuel combustion) of Brazil and CO2 emissions (% of total fuel combustion) of Germany?
Offer a terse response. -16.01. In the year 1976, what is the difference between the CO2 emissions (% of total fuel combustion) of Brazil and CO2 emissions (% of total fuel combustion) of Poland?
Offer a terse response. -13.02. In the year 1976, what is the difference between the CO2 emissions (% of total fuel combustion) in France and CO2 emissions (% of total fuel combustion) in Germany?
Provide a short and direct response. 3.22. In the year 1976, what is the difference between the CO2 emissions (% of total fuel combustion) of France and CO2 emissions (% of total fuel combustion) of Poland?
Your response must be concise. 6.21. In the year 1976, what is the difference between the CO2 emissions (% of total fuel combustion) in Germany and CO2 emissions (% of total fuel combustion) in Poland?
Make the answer very short. 2.99. In the year 1977, what is the difference between the CO2 emissions (% of total fuel combustion) of Brazil and CO2 emissions (% of total fuel combustion) of France?
Offer a very short reply. -19.58. In the year 1977, what is the difference between the CO2 emissions (% of total fuel combustion) of Brazil and CO2 emissions (% of total fuel combustion) of Germany?
Keep it short and to the point. -15.79. In the year 1977, what is the difference between the CO2 emissions (% of total fuel combustion) of Brazil and CO2 emissions (% of total fuel combustion) of Poland?
Your answer should be compact. -11.92. In the year 1977, what is the difference between the CO2 emissions (% of total fuel combustion) of France and CO2 emissions (% of total fuel combustion) of Germany?
Give a very brief answer. 3.79. In the year 1977, what is the difference between the CO2 emissions (% of total fuel combustion) in France and CO2 emissions (% of total fuel combustion) in Poland?
Give a very brief answer. 7.66. In the year 1977, what is the difference between the CO2 emissions (% of total fuel combustion) of Germany and CO2 emissions (% of total fuel combustion) of Poland?
Provide a short and direct response. 3.87. In the year 1978, what is the difference between the CO2 emissions (% of total fuel combustion) in Brazil and CO2 emissions (% of total fuel combustion) in France?
Keep it short and to the point. -21.25. In the year 1978, what is the difference between the CO2 emissions (% of total fuel combustion) in Brazil and CO2 emissions (% of total fuel combustion) in Germany?
Ensure brevity in your answer.  -15.69. In the year 1978, what is the difference between the CO2 emissions (% of total fuel combustion) in Brazil and CO2 emissions (% of total fuel combustion) in Poland?
Give a very brief answer. -12.1. In the year 1978, what is the difference between the CO2 emissions (% of total fuel combustion) in France and CO2 emissions (% of total fuel combustion) in Germany?
Keep it short and to the point. 5.56. In the year 1978, what is the difference between the CO2 emissions (% of total fuel combustion) of France and CO2 emissions (% of total fuel combustion) of Poland?
Provide a short and direct response. 9.15. In the year 1978, what is the difference between the CO2 emissions (% of total fuel combustion) in Germany and CO2 emissions (% of total fuel combustion) in Poland?
Offer a terse response. 3.59. What is the ratio of the CO2 emissions (% of total fuel combustion) of Brazil in 1972 to that in 1973?
Provide a succinct answer. 1.07. What is the ratio of the CO2 emissions (% of total fuel combustion) of France in 1972 to that in 1973?
Offer a very short reply. 0.97. What is the ratio of the CO2 emissions (% of total fuel combustion) in Poland in 1972 to that in 1973?
Offer a very short reply. 1.01. What is the ratio of the CO2 emissions (% of total fuel combustion) of Brazil in 1972 to that in 1974?
Make the answer very short. 1.17. What is the ratio of the CO2 emissions (% of total fuel combustion) in France in 1972 to that in 1974?
Ensure brevity in your answer.  1.07. What is the ratio of the CO2 emissions (% of total fuel combustion) of Germany in 1972 to that in 1974?
Your answer should be very brief. 1.09. What is the ratio of the CO2 emissions (% of total fuel combustion) in Poland in 1972 to that in 1974?
Keep it short and to the point. 1.01. What is the ratio of the CO2 emissions (% of total fuel combustion) in Brazil in 1972 to that in 1975?
Give a very brief answer. 1.21. What is the ratio of the CO2 emissions (% of total fuel combustion) in France in 1972 to that in 1975?
Provide a succinct answer. 1.05. What is the ratio of the CO2 emissions (% of total fuel combustion) of Germany in 1972 to that in 1975?
Ensure brevity in your answer.  1.07. What is the ratio of the CO2 emissions (% of total fuel combustion) in Poland in 1972 to that in 1975?
Ensure brevity in your answer.  0.98. What is the ratio of the CO2 emissions (% of total fuel combustion) of Brazil in 1972 to that in 1976?
Offer a terse response. 1.24. What is the ratio of the CO2 emissions (% of total fuel combustion) of France in 1972 to that in 1976?
Provide a short and direct response. 1.13. What is the ratio of the CO2 emissions (% of total fuel combustion) of Germany in 1972 to that in 1976?
Offer a very short reply. 1.05. What is the ratio of the CO2 emissions (% of total fuel combustion) of Poland in 1972 to that in 1976?
Provide a short and direct response. 0.95. What is the ratio of the CO2 emissions (% of total fuel combustion) in Brazil in 1972 to that in 1977?
Provide a succinct answer. 1.26. What is the ratio of the CO2 emissions (% of total fuel combustion) in France in 1972 to that in 1977?
Give a very brief answer. 1.12. What is the ratio of the CO2 emissions (% of total fuel combustion) of Germany in 1972 to that in 1977?
Provide a short and direct response. 1.07. What is the ratio of the CO2 emissions (% of total fuel combustion) in Poland in 1972 to that in 1977?
Ensure brevity in your answer.  1.02. What is the ratio of the CO2 emissions (% of total fuel combustion) of Brazil in 1972 to that in 1978?
Your answer should be compact. 1.28. What is the ratio of the CO2 emissions (% of total fuel combustion) of France in 1972 to that in 1978?
Provide a succinct answer. 1.05. What is the ratio of the CO2 emissions (% of total fuel combustion) of Germany in 1972 to that in 1978?
Offer a terse response. 1.08. What is the ratio of the CO2 emissions (% of total fuel combustion) of Poland in 1972 to that in 1978?
Ensure brevity in your answer.  1.01. What is the ratio of the CO2 emissions (% of total fuel combustion) of Brazil in 1973 to that in 1974?
Keep it short and to the point. 1.09. What is the ratio of the CO2 emissions (% of total fuel combustion) of France in 1973 to that in 1974?
Provide a succinct answer. 1.1. What is the ratio of the CO2 emissions (% of total fuel combustion) of Germany in 1973 to that in 1974?
Your answer should be compact. 1.09. What is the ratio of the CO2 emissions (% of total fuel combustion) in Brazil in 1973 to that in 1975?
Keep it short and to the point. 1.13. What is the ratio of the CO2 emissions (% of total fuel combustion) in France in 1973 to that in 1975?
Provide a succinct answer. 1.09. What is the ratio of the CO2 emissions (% of total fuel combustion) in Germany in 1973 to that in 1975?
Provide a short and direct response. 1.07. What is the ratio of the CO2 emissions (% of total fuel combustion) of Poland in 1973 to that in 1975?
Offer a terse response. 0.97. What is the ratio of the CO2 emissions (% of total fuel combustion) of Brazil in 1973 to that in 1976?
Make the answer very short. 1.16. What is the ratio of the CO2 emissions (% of total fuel combustion) of France in 1973 to that in 1976?
Offer a very short reply. 1.17. What is the ratio of the CO2 emissions (% of total fuel combustion) of Germany in 1973 to that in 1976?
Ensure brevity in your answer.  1.05. What is the ratio of the CO2 emissions (% of total fuel combustion) in Poland in 1973 to that in 1976?
Give a very brief answer. 0.94. What is the ratio of the CO2 emissions (% of total fuel combustion) of Brazil in 1973 to that in 1977?
Your answer should be compact. 1.18. What is the ratio of the CO2 emissions (% of total fuel combustion) of France in 1973 to that in 1977?
Make the answer very short. 1.16. What is the ratio of the CO2 emissions (% of total fuel combustion) of Germany in 1973 to that in 1977?
Keep it short and to the point. 1.07. What is the ratio of the CO2 emissions (% of total fuel combustion) of Brazil in 1973 to that in 1978?
Your response must be concise. 1.2. What is the ratio of the CO2 emissions (% of total fuel combustion) of France in 1973 to that in 1978?
Make the answer very short. 1.09. What is the ratio of the CO2 emissions (% of total fuel combustion) of Germany in 1973 to that in 1978?
Your answer should be very brief. 1.08. What is the ratio of the CO2 emissions (% of total fuel combustion) of Poland in 1973 to that in 1978?
Provide a short and direct response. 1. What is the ratio of the CO2 emissions (% of total fuel combustion) of Brazil in 1974 to that in 1975?
Your answer should be compact. 1.03. What is the ratio of the CO2 emissions (% of total fuel combustion) in France in 1974 to that in 1975?
Your answer should be very brief. 0.99. What is the ratio of the CO2 emissions (% of total fuel combustion) of Germany in 1974 to that in 1975?
Give a very brief answer. 0.98. What is the ratio of the CO2 emissions (% of total fuel combustion) of Poland in 1974 to that in 1975?
Provide a short and direct response. 0.97. What is the ratio of the CO2 emissions (% of total fuel combustion) of Brazil in 1974 to that in 1976?
Provide a succinct answer. 1.06. What is the ratio of the CO2 emissions (% of total fuel combustion) of France in 1974 to that in 1976?
Offer a very short reply. 1.06. What is the ratio of the CO2 emissions (% of total fuel combustion) in Germany in 1974 to that in 1976?
Ensure brevity in your answer.  0.97. What is the ratio of the CO2 emissions (% of total fuel combustion) of Poland in 1974 to that in 1976?
Ensure brevity in your answer.  0.94. What is the ratio of the CO2 emissions (% of total fuel combustion) in Brazil in 1974 to that in 1977?
Give a very brief answer. 1.08. What is the ratio of the CO2 emissions (% of total fuel combustion) of France in 1974 to that in 1977?
Your response must be concise. 1.05. What is the ratio of the CO2 emissions (% of total fuel combustion) of Poland in 1974 to that in 1977?
Give a very brief answer. 1.01. What is the ratio of the CO2 emissions (% of total fuel combustion) in Brazil in 1974 to that in 1978?
Your response must be concise. 1.1. What is the ratio of the CO2 emissions (% of total fuel combustion) of Germany in 1974 to that in 1978?
Offer a terse response. 0.99. What is the ratio of the CO2 emissions (% of total fuel combustion) of Brazil in 1975 to that in 1976?
Offer a very short reply. 1.03. What is the ratio of the CO2 emissions (% of total fuel combustion) of France in 1975 to that in 1976?
Your answer should be compact. 1.07. What is the ratio of the CO2 emissions (% of total fuel combustion) of Germany in 1975 to that in 1976?
Give a very brief answer. 0.99. What is the ratio of the CO2 emissions (% of total fuel combustion) in Poland in 1975 to that in 1976?
Give a very brief answer. 0.97. What is the ratio of the CO2 emissions (% of total fuel combustion) of Brazil in 1975 to that in 1977?
Provide a short and direct response. 1.04. What is the ratio of the CO2 emissions (% of total fuel combustion) in France in 1975 to that in 1977?
Provide a succinct answer. 1.06. What is the ratio of the CO2 emissions (% of total fuel combustion) in Poland in 1975 to that in 1977?
Provide a short and direct response. 1.04. What is the ratio of the CO2 emissions (% of total fuel combustion) of Brazil in 1975 to that in 1978?
Ensure brevity in your answer.  1.06. What is the ratio of the CO2 emissions (% of total fuel combustion) in Germany in 1975 to that in 1978?
Make the answer very short. 1.01. What is the ratio of the CO2 emissions (% of total fuel combustion) of Poland in 1975 to that in 1978?
Ensure brevity in your answer.  1.03. What is the ratio of the CO2 emissions (% of total fuel combustion) in Brazil in 1976 to that in 1977?
Ensure brevity in your answer.  1.02. What is the ratio of the CO2 emissions (% of total fuel combustion) in France in 1976 to that in 1977?
Give a very brief answer. 0.99. What is the ratio of the CO2 emissions (% of total fuel combustion) in Germany in 1976 to that in 1977?
Make the answer very short. 1.02. What is the ratio of the CO2 emissions (% of total fuel combustion) in Poland in 1976 to that in 1977?
Your answer should be compact. 1.07. What is the ratio of the CO2 emissions (% of total fuel combustion) in Brazil in 1976 to that in 1978?
Keep it short and to the point. 1.03. What is the ratio of the CO2 emissions (% of total fuel combustion) of France in 1976 to that in 1978?
Your answer should be compact. 0.93. What is the ratio of the CO2 emissions (% of total fuel combustion) of Germany in 1976 to that in 1978?
Make the answer very short. 1.02. What is the ratio of the CO2 emissions (% of total fuel combustion) in Poland in 1976 to that in 1978?
Provide a succinct answer. 1.06. What is the ratio of the CO2 emissions (% of total fuel combustion) of Brazil in 1977 to that in 1978?
Make the answer very short. 1.02. What is the ratio of the CO2 emissions (% of total fuel combustion) of France in 1977 to that in 1978?
Your answer should be compact. 0.94. What is the ratio of the CO2 emissions (% of total fuel combustion) in Germany in 1977 to that in 1978?
Offer a very short reply. 1.01. What is the ratio of the CO2 emissions (% of total fuel combustion) in Poland in 1977 to that in 1978?
Offer a very short reply. 0.99. What is the difference between the highest and the second highest CO2 emissions (% of total fuel combustion) in Brazil?
Offer a terse response. 0.44. What is the difference between the highest and the second highest CO2 emissions (% of total fuel combustion) in France?
Your answer should be compact. 0.96. What is the difference between the highest and the second highest CO2 emissions (% of total fuel combustion) in Germany?
Your answer should be compact. 0.04. What is the difference between the highest and the second highest CO2 emissions (% of total fuel combustion) in Poland?
Make the answer very short. 0.5. What is the difference between the highest and the lowest CO2 emissions (% of total fuel combustion) of Brazil?
Your response must be concise. 1.47. What is the difference between the highest and the lowest CO2 emissions (% of total fuel combustion) of France?
Your answer should be very brief. 4.2. What is the difference between the highest and the lowest CO2 emissions (% of total fuel combustion) of Germany?
Give a very brief answer. 1.87. What is the difference between the highest and the lowest CO2 emissions (% of total fuel combustion) in Poland?
Your answer should be very brief. 1.2. 